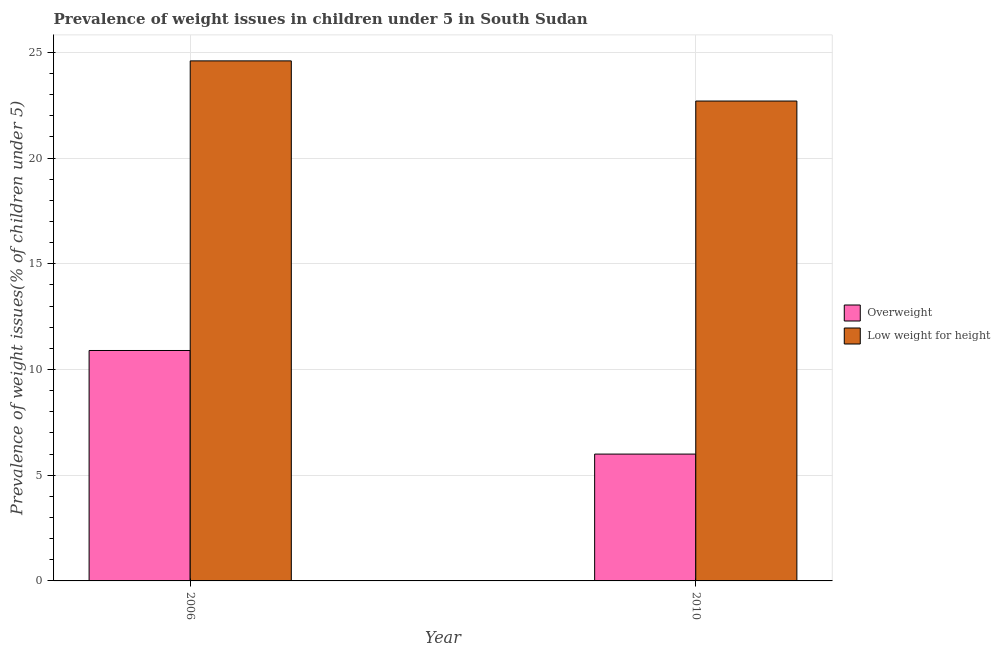How many different coloured bars are there?
Your response must be concise. 2. Are the number of bars per tick equal to the number of legend labels?
Keep it short and to the point. Yes. How many bars are there on the 1st tick from the right?
Make the answer very short. 2. What is the label of the 1st group of bars from the left?
Keep it short and to the point. 2006. In how many cases, is the number of bars for a given year not equal to the number of legend labels?
Provide a succinct answer. 0. Across all years, what is the maximum percentage of underweight children?
Ensure brevity in your answer.  24.6. Across all years, what is the minimum percentage of underweight children?
Offer a very short reply. 22.7. What is the total percentage of overweight children in the graph?
Your response must be concise. 16.9. What is the difference between the percentage of underweight children in 2006 and that in 2010?
Provide a short and direct response. 1.9. What is the difference between the percentage of underweight children in 2010 and the percentage of overweight children in 2006?
Give a very brief answer. -1.9. What is the average percentage of overweight children per year?
Offer a terse response. 8.45. In the year 2006, what is the difference between the percentage of underweight children and percentage of overweight children?
Make the answer very short. 0. In how many years, is the percentage of underweight children greater than 3 %?
Ensure brevity in your answer.  2. What is the ratio of the percentage of overweight children in 2006 to that in 2010?
Ensure brevity in your answer.  1.82. Is the percentage of underweight children in 2006 less than that in 2010?
Offer a terse response. No. What does the 2nd bar from the left in 2006 represents?
Give a very brief answer. Low weight for height. What does the 1st bar from the right in 2010 represents?
Your response must be concise. Low weight for height. How many years are there in the graph?
Offer a very short reply. 2. What is the difference between two consecutive major ticks on the Y-axis?
Your answer should be compact. 5. Does the graph contain any zero values?
Provide a succinct answer. No. Does the graph contain grids?
Provide a succinct answer. Yes. Where does the legend appear in the graph?
Give a very brief answer. Center right. What is the title of the graph?
Make the answer very short. Prevalence of weight issues in children under 5 in South Sudan. What is the label or title of the Y-axis?
Keep it short and to the point. Prevalence of weight issues(% of children under 5). What is the Prevalence of weight issues(% of children under 5) of Overweight in 2006?
Provide a succinct answer. 10.9. What is the Prevalence of weight issues(% of children under 5) in Low weight for height in 2006?
Make the answer very short. 24.6. What is the Prevalence of weight issues(% of children under 5) of Overweight in 2010?
Give a very brief answer. 6. What is the Prevalence of weight issues(% of children under 5) in Low weight for height in 2010?
Provide a short and direct response. 22.7. Across all years, what is the maximum Prevalence of weight issues(% of children under 5) of Overweight?
Provide a succinct answer. 10.9. Across all years, what is the maximum Prevalence of weight issues(% of children under 5) of Low weight for height?
Give a very brief answer. 24.6. Across all years, what is the minimum Prevalence of weight issues(% of children under 5) of Low weight for height?
Make the answer very short. 22.7. What is the total Prevalence of weight issues(% of children under 5) in Overweight in the graph?
Your response must be concise. 16.9. What is the total Prevalence of weight issues(% of children under 5) of Low weight for height in the graph?
Provide a succinct answer. 47.3. What is the difference between the Prevalence of weight issues(% of children under 5) of Overweight in 2006 and that in 2010?
Make the answer very short. 4.9. What is the difference between the Prevalence of weight issues(% of children under 5) in Low weight for height in 2006 and that in 2010?
Make the answer very short. 1.9. What is the difference between the Prevalence of weight issues(% of children under 5) in Overweight in 2006 and the Prevalence of weight issues(% of children under 5) in Low weight for height in 2010?
Provide a short and direct response. -11.8. What is the average Prevalence of weight issues(% of children under 5) in Overweight per year?
Make the answer very short. 8.45. What is the average Prevalence of weight issues(% of children under 5) in Low weight for height per year?
Your response must be concise. 23.65. In the year 2006, what is the difference between the Prevalence of weight issues(% of children under 5) of Overweight and Prevalence of weight issues(% of children under 5) of Low weight for height?
Ensure brevity in your answer.  -13.7. In the year 2010, what is the difference between the Prevalence of weight issues(% of children under 5) of Overweight and Prevalence of weight issues(% of children under 5) of Low weight for height?
Provide a short and direct response. -16.7. What is the ratio of the Prevalence of weight issues(% of children under 5) in Overweight in 2006 to that in 2010?
Your response must be concise. 1.82. What is the ratio of the Prevalence of weight issues(% of children under 5) of Low weight for height in 2006 to that in 2010?
Offer a terse response. 1.08. What is the difference between the highest and the lowest Prevalence of weight issues(% of children under 5) in Overweight?
Your response must be concise. 4.9. 